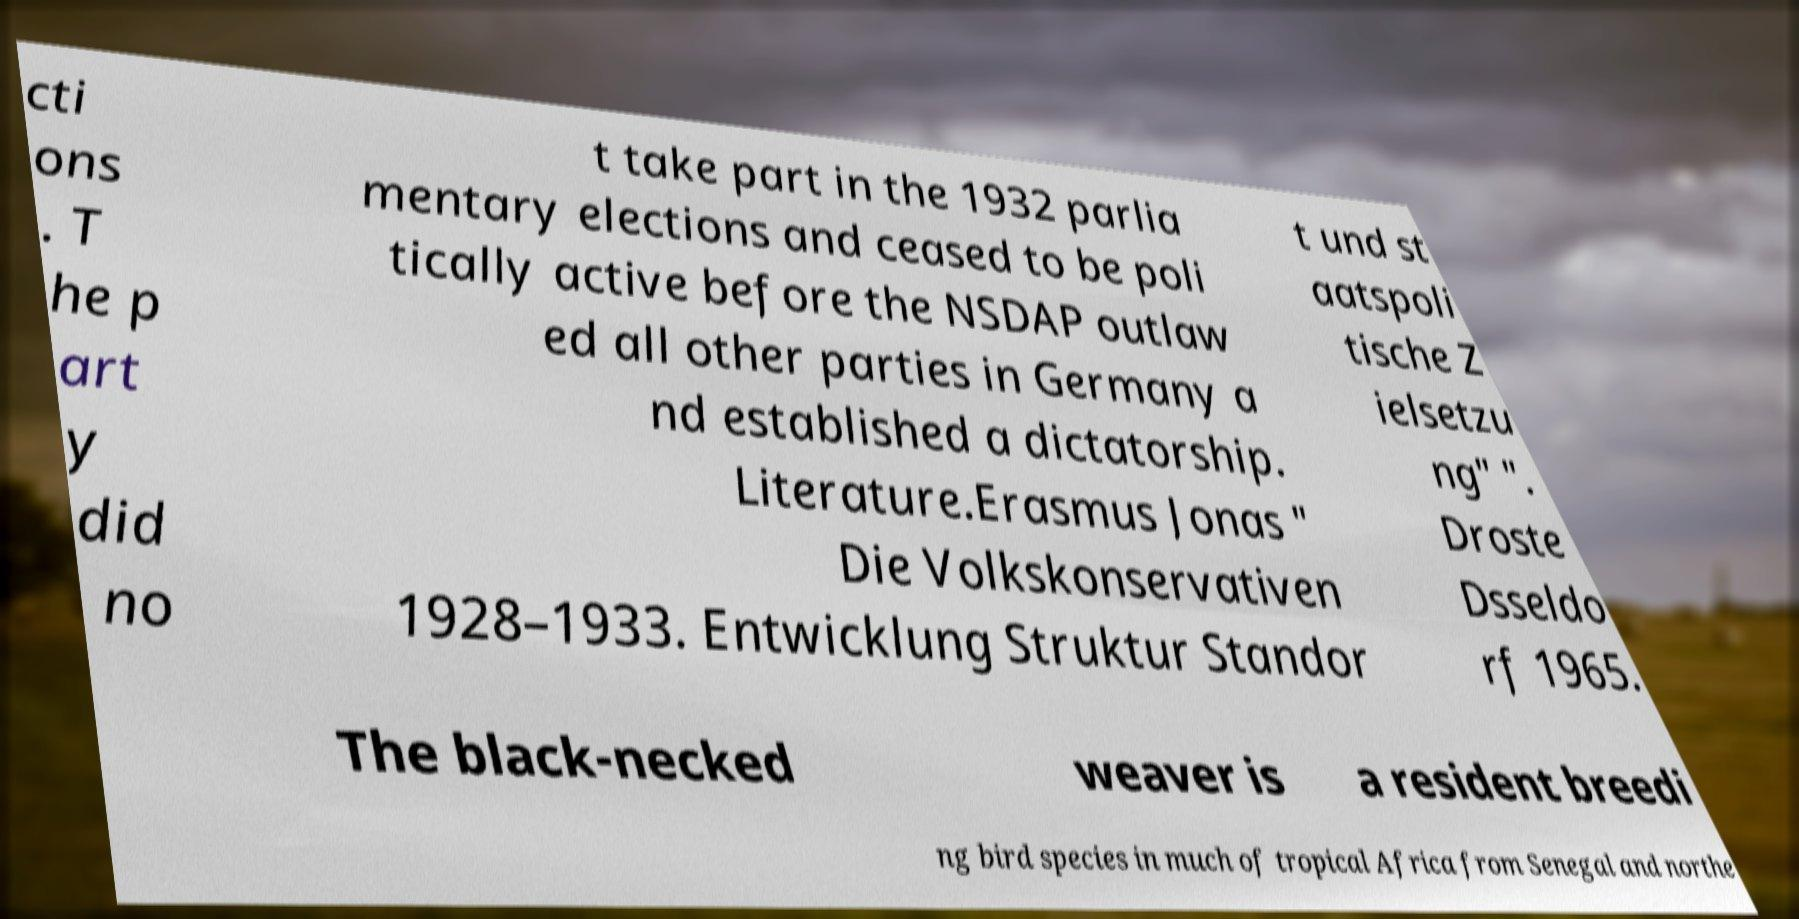What messages or text are displayed in this image? I need them in a readable, typed format. cti ons . T he p art y did no t take part in the 1932 parlia mentary elections and ceased to be poli tically active before the NSDAP outlaw ed all other parties in Germany a nd established a dictatorship. Literature.Erasmus Jonas " Die Volkskonservativen 1928–1933. Entwicklung Struktur Standor t und st aatspoli tische Z ielsetzu ng" ". Droste Dsseldo rf 1965. The black-necked weaver is a resident breedi ng bird species in much of tropical Africa from Senegal and northe 